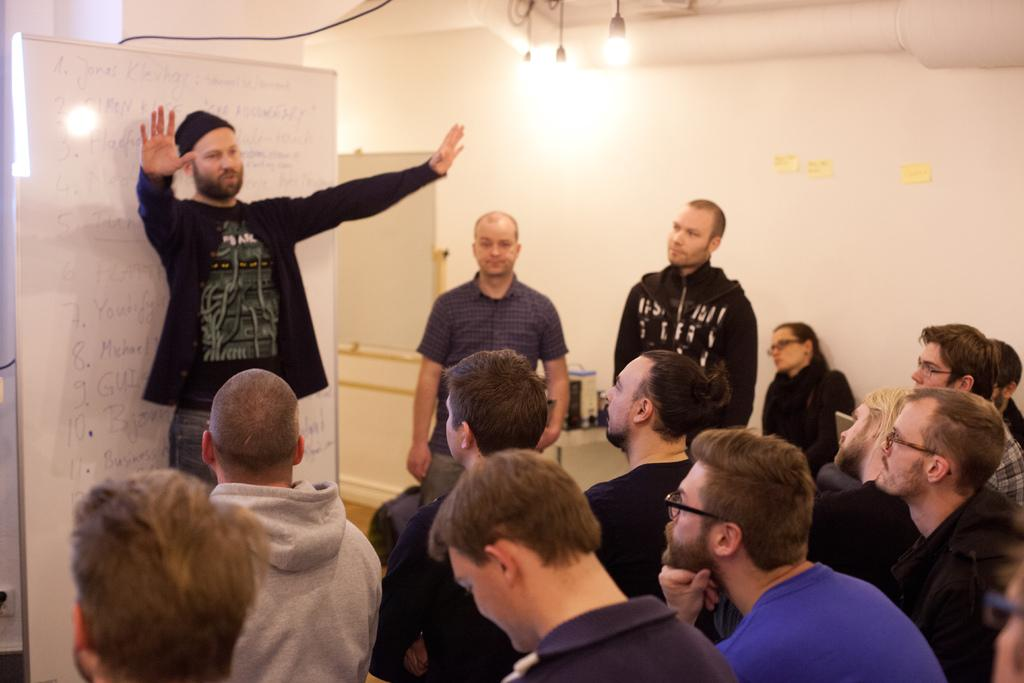How many people are in the image? There is a group of people in the image. What are the people in the image doing? Some people are seated, while others are standing. What can be seen in the background of the image? There is a board and lights visible in the background of the image. What type of instrument is being played by the person standing next to the vase in the image? There is no vase or person playing an instrument present in the image. 